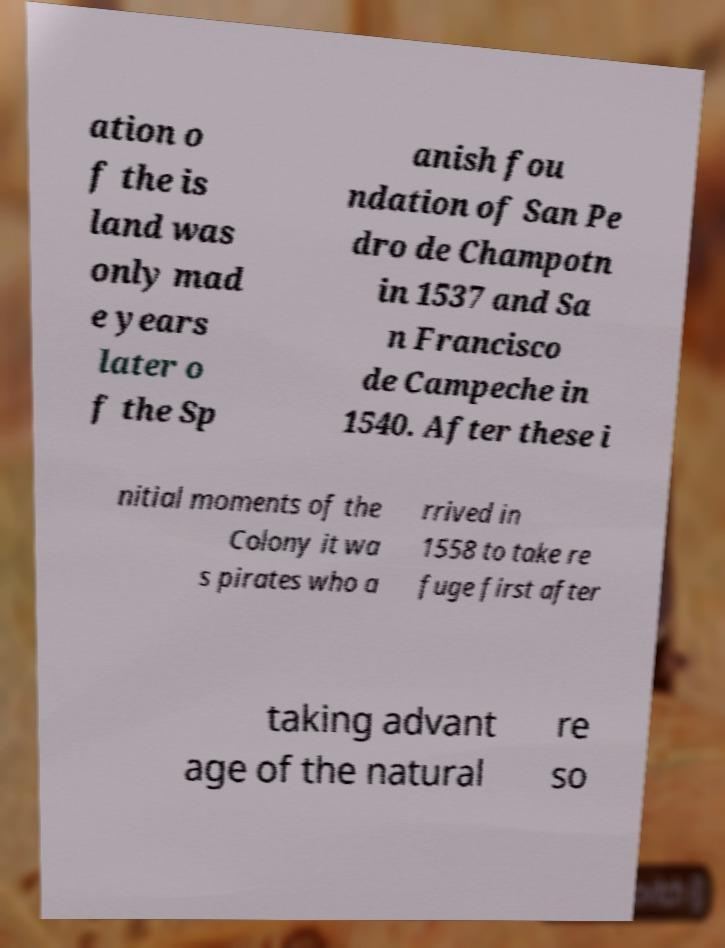Can you read and provide the text displayed in the image?This photo seems to have some interesting text. Can you extract and type it out for me? ation o f the is land was only mad e years later o f the Sp anish fou ndation of San Pe dro de Champotn in 1537 and Sa n Francisco de Campeche in 1540. After these i nitial moments of the Colony it wa s pirates who a rrived in 1558 to take re fuge first after taking advant age of the natural re so 